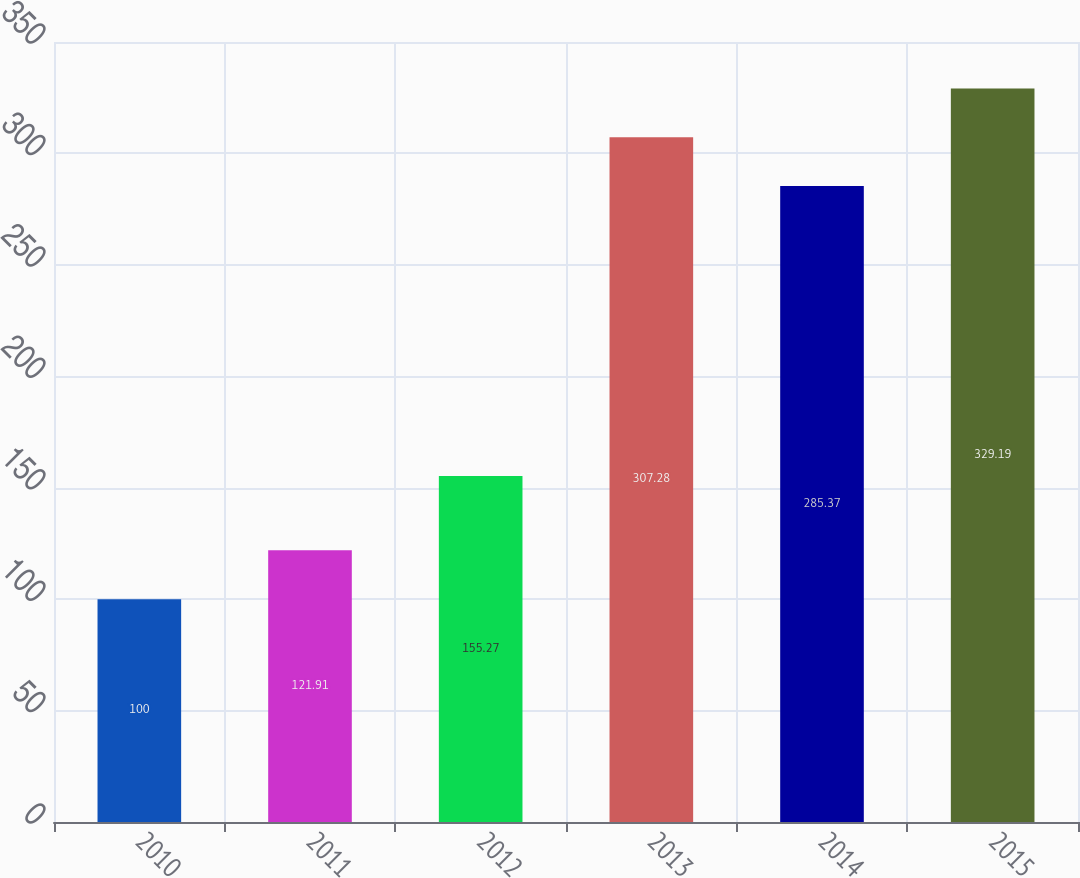Convert chart to OTSL. <chart><loc_0><loc_0><loc_500><loc_500><bar_chart><fcel>2010<fcel>2011<fcel>2012<fcel>2013<fcel>2014<fcel>2015<nl><fcel>100<fcel>121.91<fcel>155.27<fcel>307.28<fcel>285.37<fcel>329.19<nl></chart> 